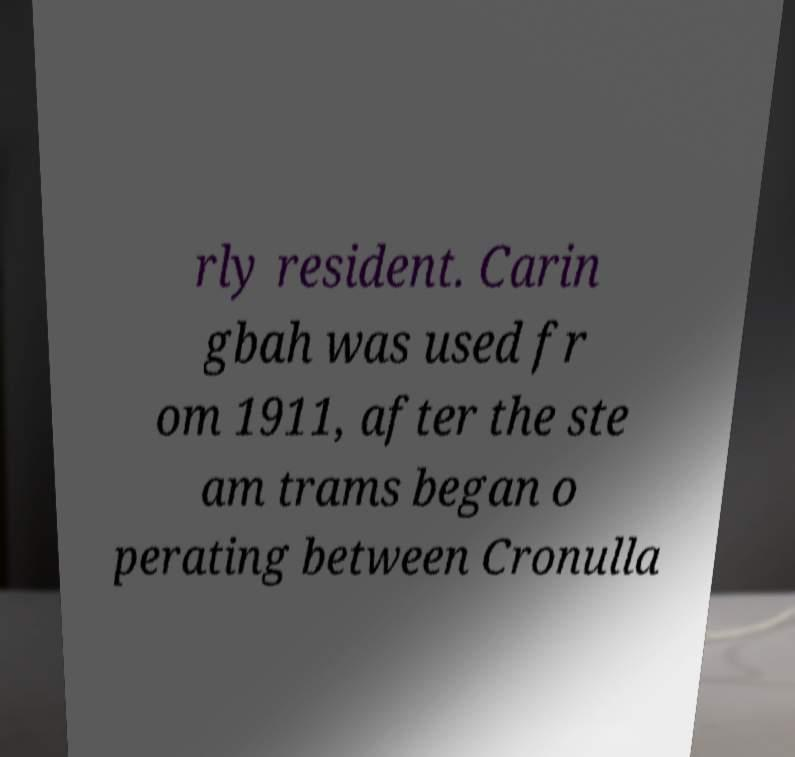What messages or text are displayed in this image? I need them in a readable, typed format. rly resident. Carin gbah was used fr om 1911, after the ste am trams began o perating between Cronulla 